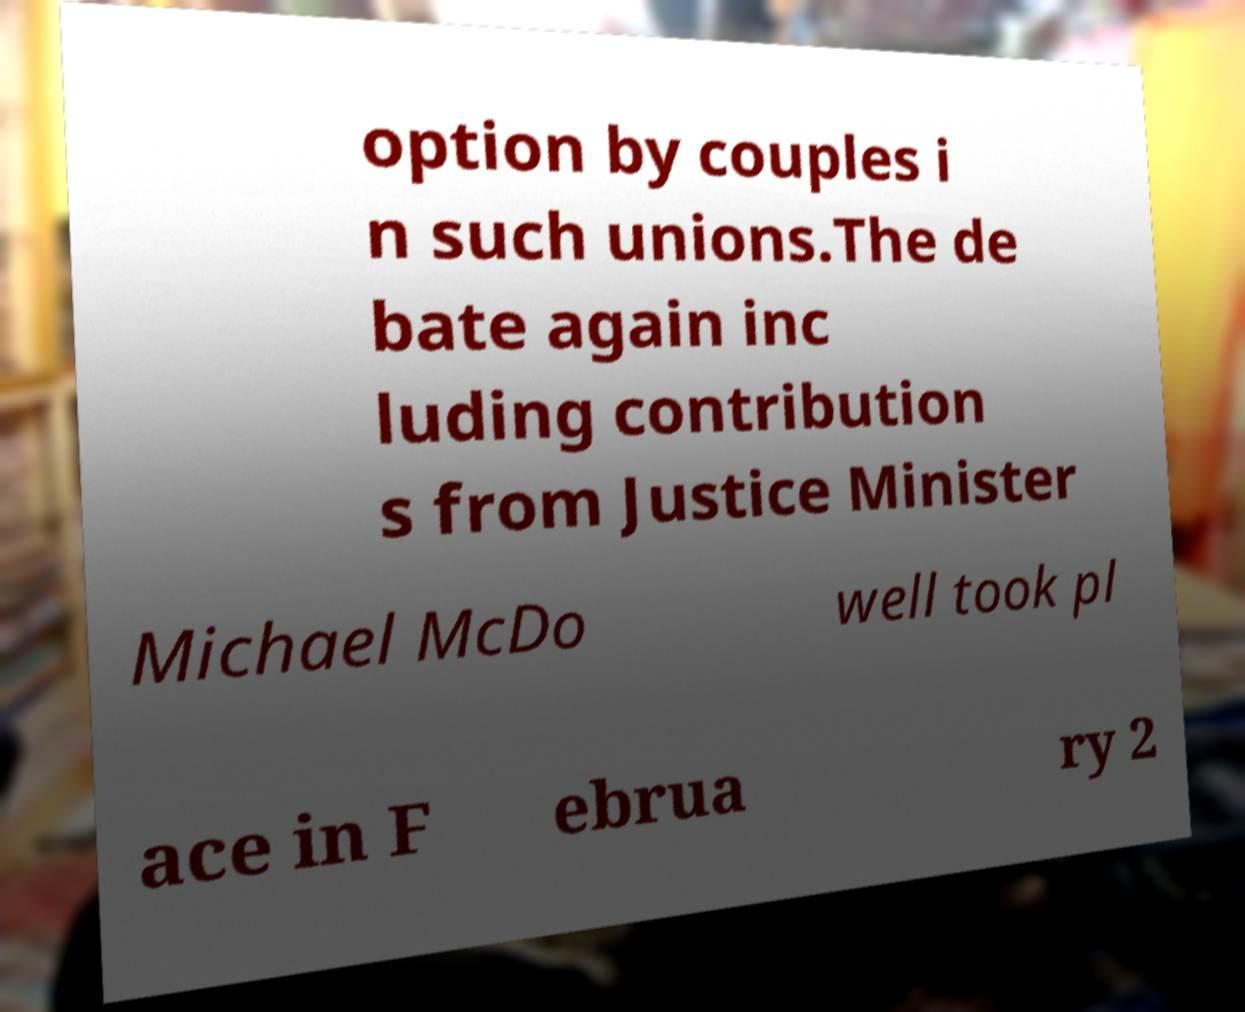Could you assist in decoding the text presented in this image and type it out clearly? option by couples i n such unions.The de bate again inc luding contribution s from Justice Minister Michael McDo well took pl ace in F ebrua ry 2 